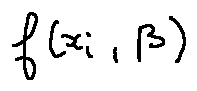<formula> <loc_0><loc_0><loc_500><loc_500>f ( x _ { i } , \beta )</formula> 